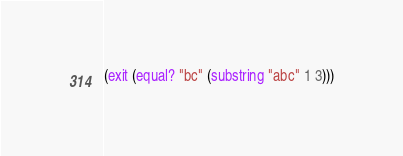Convert code to text. <code><loc_0><loc_0><loc_500><loc_500><_Scheme_>(exit (equal? "bc" (substring "abc" 1 3)))
</code> 